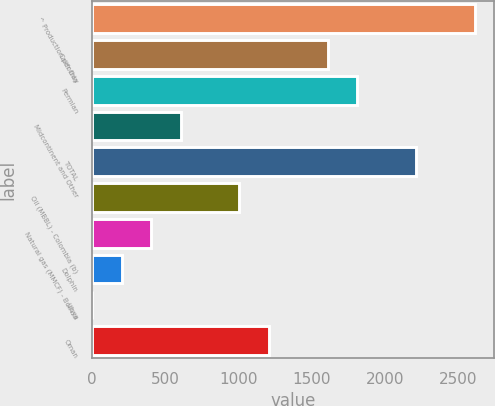<chart> <loc_0><loc_0><loc_500><loc_500><bar_chart><fcel>^ Production per Day<fcel>California<fcel>Permian<fcel>Midcontinent and Other<fcel>TOTAL<fcel>Oil (MBBL) - Colombia (b)<fcel>Natural gas (MMCF) - Bolivia<fcel>Dolphin<fcel>Libya<fcel>Oman<nl><fcel>2613.1<fcel>1609.6<fcel>1810.3<fcel>606.1<fcel>2211.7<fcel>1007.5<fcel>405.4<fcel>204.7<fcel>4<fcel>1208.2<nl></chart> 